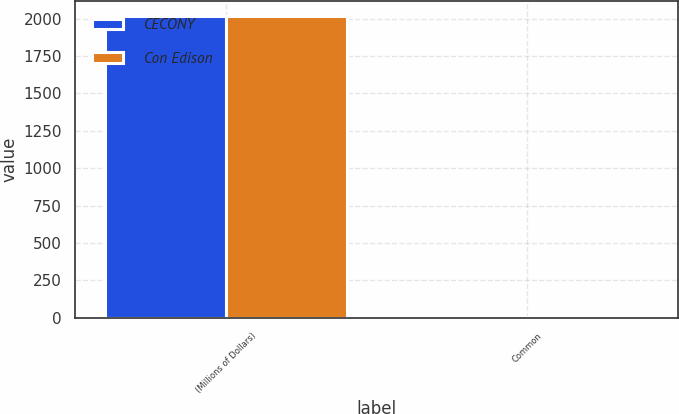<chart> <loc_0><loc_0><loc_500><loc_500><stacked_bar_chart><ecel><fcel>(Millions of Dollars)<fcel>Common<nl><fcel>CECONY<fcel>2015<fcel>3<nl><fcel>Con Edison<fcel>2015<fcel>2<nl></chart> 